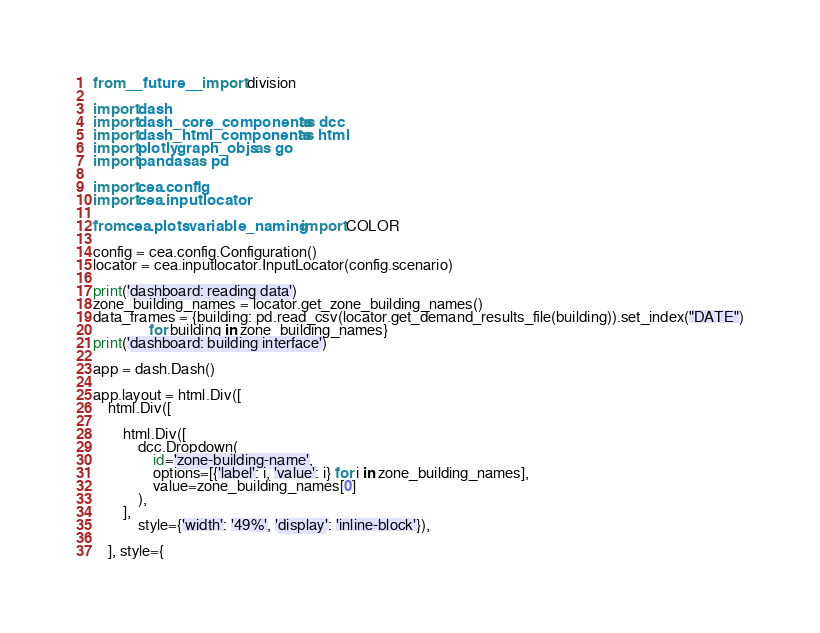Convert code to text. <code><loc_0><loc_0><loc_500><loc_500><_Python_>from __future__ import division

import dash
import dash_core_components as dcc
import dash_html_components as html
import plotly.graph_objs as go
import pandas as pd

import cea.config
import cea.inputlocator

from cea.plots.variable_naming import COLOR

config = cea.config.Configuration()
locator = cea.inputlocator.InputLocator(config.scenario)

print('dashboard: reading data')
zone_building_names = locator.get_zone_building_names()
data_frames = {building: pd.read_csv(locator.get_demand_results_file(building)).set_index("DATE")
               for building in zone_building_names}
print('dashboard: building interface')

app = dash.Dash()

app.layout = html.Div([
    html.Div([

        html.Div([
            dcc.Dropdown(
                id='zone-building-name',
                options=[{'label': i, 'value': i} for i in zone_building_names],
                value=zone_building_names[0]
            ),
        ],
            style={'width': '49%', 'display': 'inline-block'}),

    ], style={</code> 